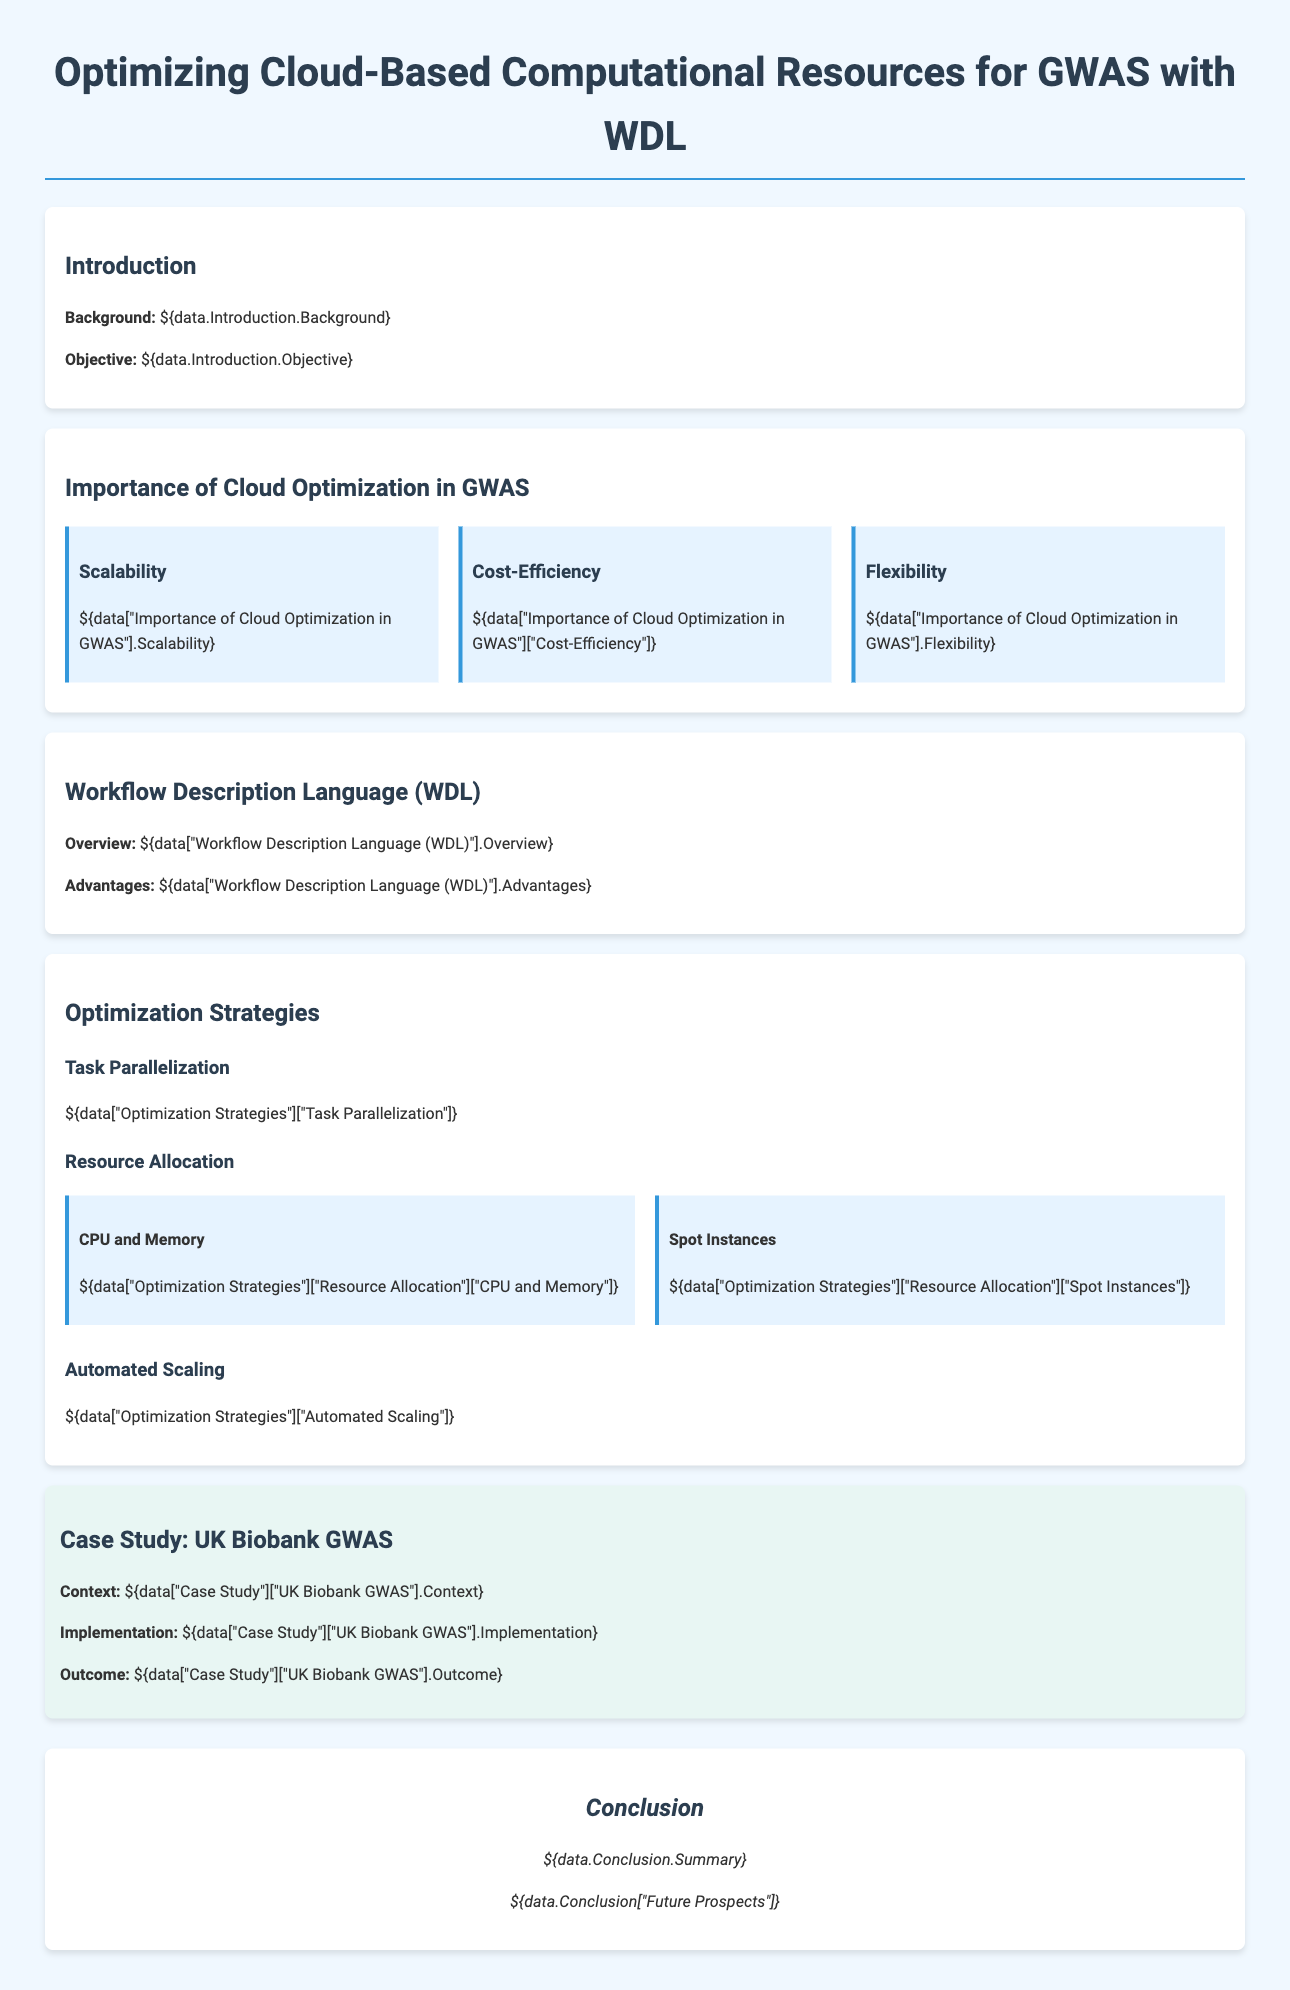What is the background of the proposal? The background is detailed in the Introduction section of the document.
Answer: Background: ${data.Introduction.Background} What is the objective of the proposal? The objective is stated in the Introduction section.
Answer: Objective: ${data.Introduction.Objective} What are the three importance factors of cloud optimization in GWAS? The document mentions Scalability, Cost-Efficiency, and Flexibility under the importance factors.
Answer: Scalability, Cost-Efficiency, Flexibility What are two advantages of using WDL? The advantages of WDL are included in the Workflow Description Language section.
Answer: Advantages: ${data["Workflow Description Language (WDL)"].Advantages} What optimization strategy involves improving resource management? The strategy that enhances resource management is included in the Optimization Strategies section regarding CPU and Memory.
Answer: Resource Allocation What case study is referred to in the proposal? The proposal references a specific case study in the section identified as Case Study.
Answer: UK Biobank GWAS What is a significant outcome of the UK Biobank GWAS implementation? The outcome is described in the Case Study section for UK Biobank GWAS.
Answer: Outcome: ${data["Case Study"]["UK Biobank GWAS"].Outcome} What is automated scaling? Automated Scaling is described under the Optimization Strategies section, elaborating on a specific approach.
Answer: ${data["Optimization Strategies"]["Automated Scaling"]} What is the primary focus of the conclusion in the proposal? The conclusion summarizes the proposal and its future prospects.
Answer: Summary: ${data.Conclusion.Summary} What is the document type? This information is indicative of the nature of the document.
Answer: Proposal 